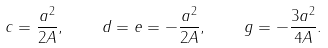Convert formula to latex. <formula><loc_0><loc_0><loc_500><loc_500>c = \frac { a ^ { 2 } } { 2 A } , \quad d = e = - \frac { a ^ { 2 } } { 2 A } , \quad g = - \frac { 3 a ^ { 2 } } { 4 A } .</formula> 